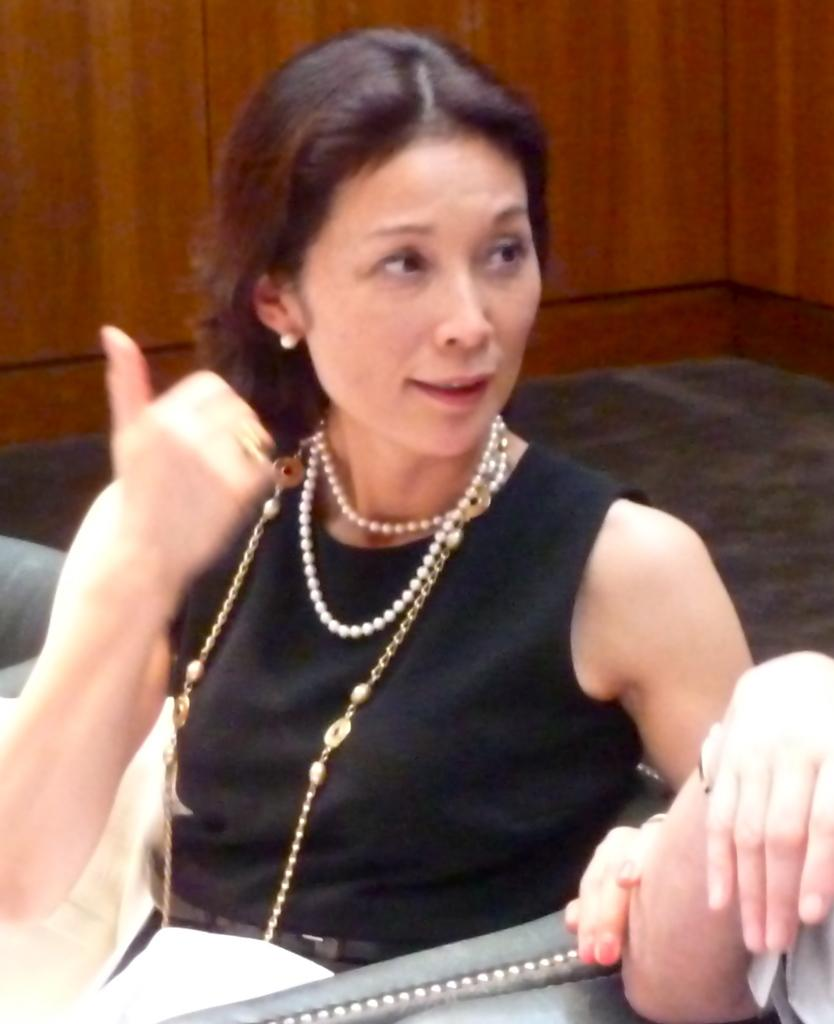How many chairs are in the image? There are three chairs in the image. What is the woman in the black dress doing? The woman in the black dress is sitting on one of the chairs. What can be seen in the image besides the chairs and the woman? There is a paper and a person's hand visible in the image. What is on the floor in the image? There is a carpet on the floor in the image. What type of wall is visible in the background of the image? The background of the image includes a wooden wall. How many feet are visible in the image? There is no foot visible in the image; only a person's hand is present. What type of discussion is taking place in the image? There is no discussion taking place in the image; it only shows a woman sitting on a chair, a paper, and a person's hand. 